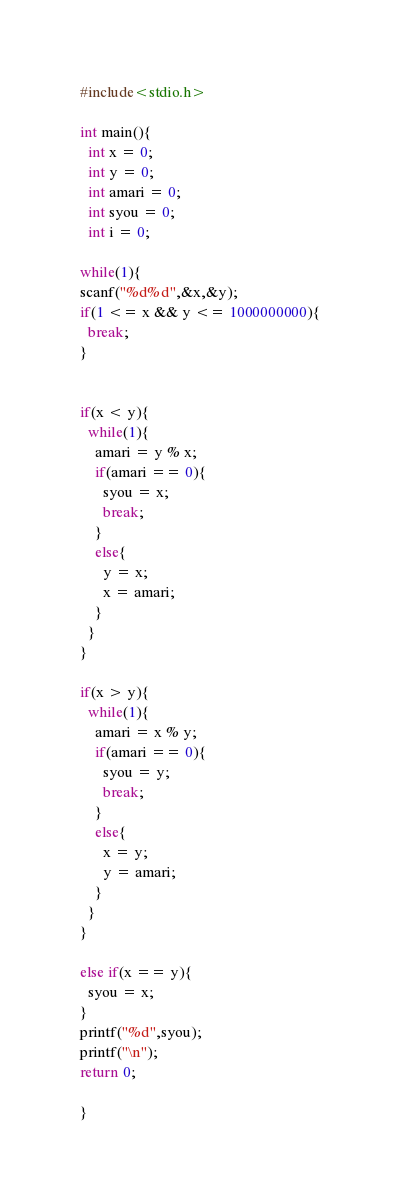Convert code to text. <code><loc_0><loc_0><loc_500><loc_500><_C_>#include<stdio.h>

int main(){
  int x = 0;
  int y = 0;
  int amari = 0;
  int syou = 0;
  int i = 0;

while(1){
scanf("%d%d",&x,&y);
if(1 <= x && y <= 1000000000){
  break;
}


if(x < y){
  while(1){
    amari = y % x;
    if(amari == 0){
      syou = x;
      break;
    }
    else{
      y = x;
      x = amari;
    }
  }
}

if(x > y){
  while(1){
    amari = x % y;
    if(amari == 0){
      syou = y;
      break;
    }
    else{
      x = y;
      y = amari;
    }
  }
}

else if(x == y){
  syou = x;
}
printf("%d",syou);
printf("\n");
return 0;

}

</code> 